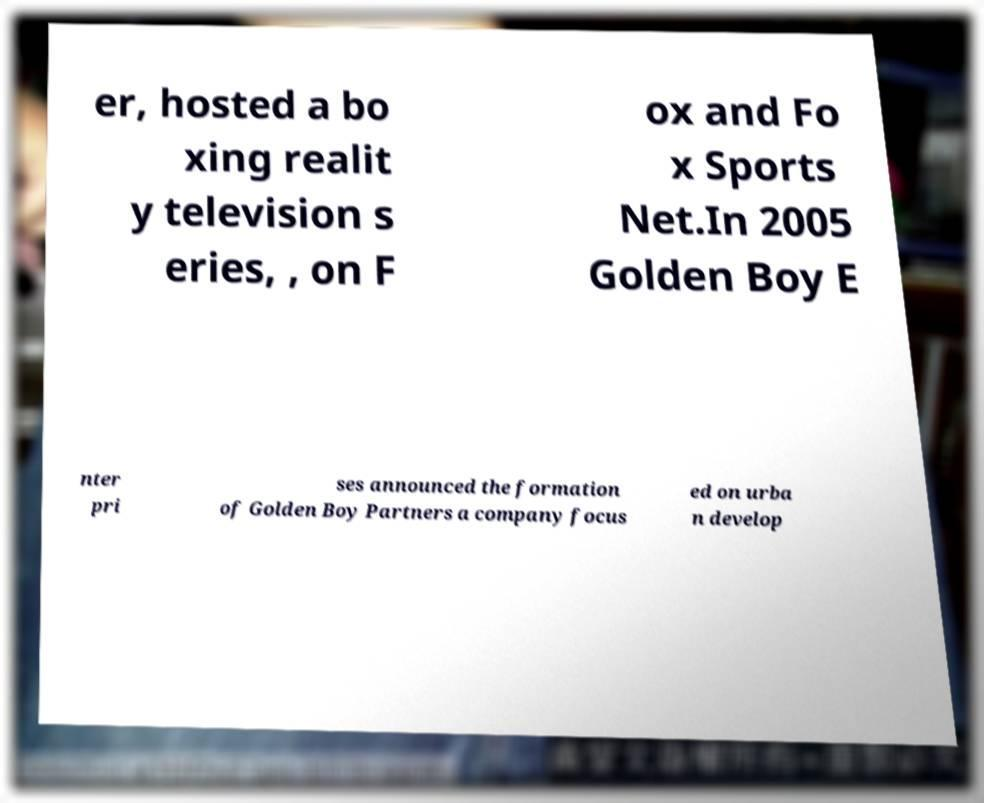There's text embedded in this image that I need extracted. Can you transcribe it verbatim? er, hosted a bo xing realit y television s eries, , on F ox and Fo x Sports Net.In 2005 Golden Boy E nter pri ses announced the formation of Golden Boy Partners a company focus ed on urba n develop 